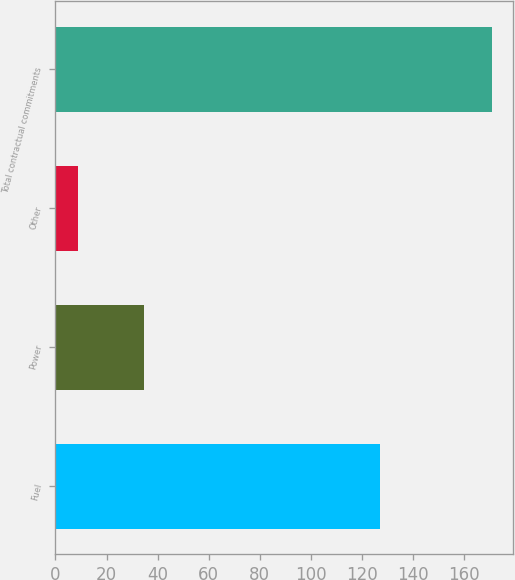Convert chart. <chart><loc_0><loc_0><loc_500><loc_500><bar_chart><fcel>Fuel<fcel>Power<fcel>Other<fcel>Total contractual commitments<nl><fcel>126.9<fcel>34.8<fcel>9<fcel>170.7<nl></chart> 